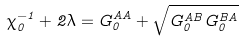<formula> <loc_0><loc_0><loc_500><loc_500>\chi _ { 0 } ^ { - 1 } + 2 \lambda = G _ { 0 } ^ { A A } + \sqrt { G _ { 0 } ^ { A B } G _ { 0 } ^ { B A } }</formula> 